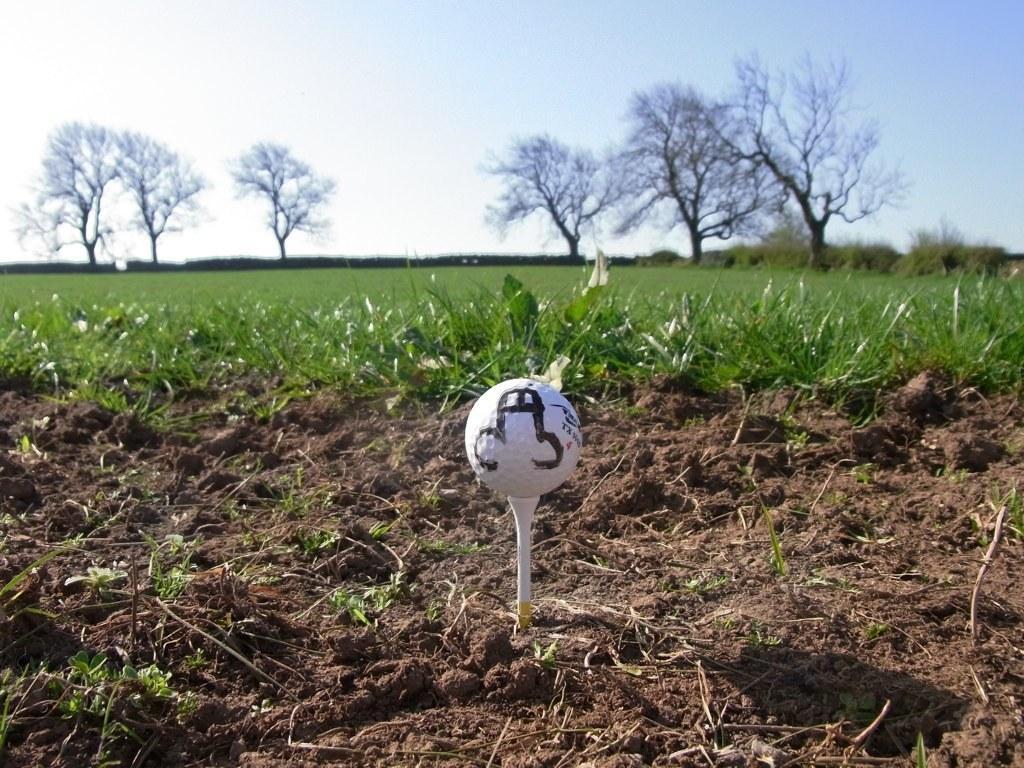Describe this image in one or two sentences. In this image there is the sky towards the top of the image, there are trees, there is grass, there is soil towards the bottom of the image, there is a ball on an object. 